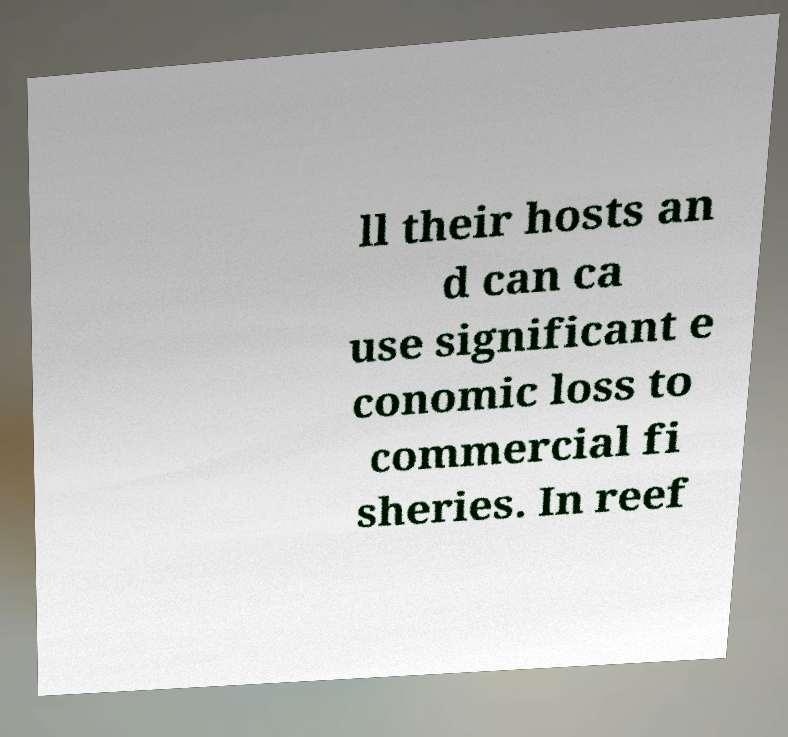Can you read and provide the text displayed in the image?This photo seems to have some interesting text. Can you extract and type it out for me? ll their hosts an d can ca use significant e conomic loss to commercial fi sheries. In reef 